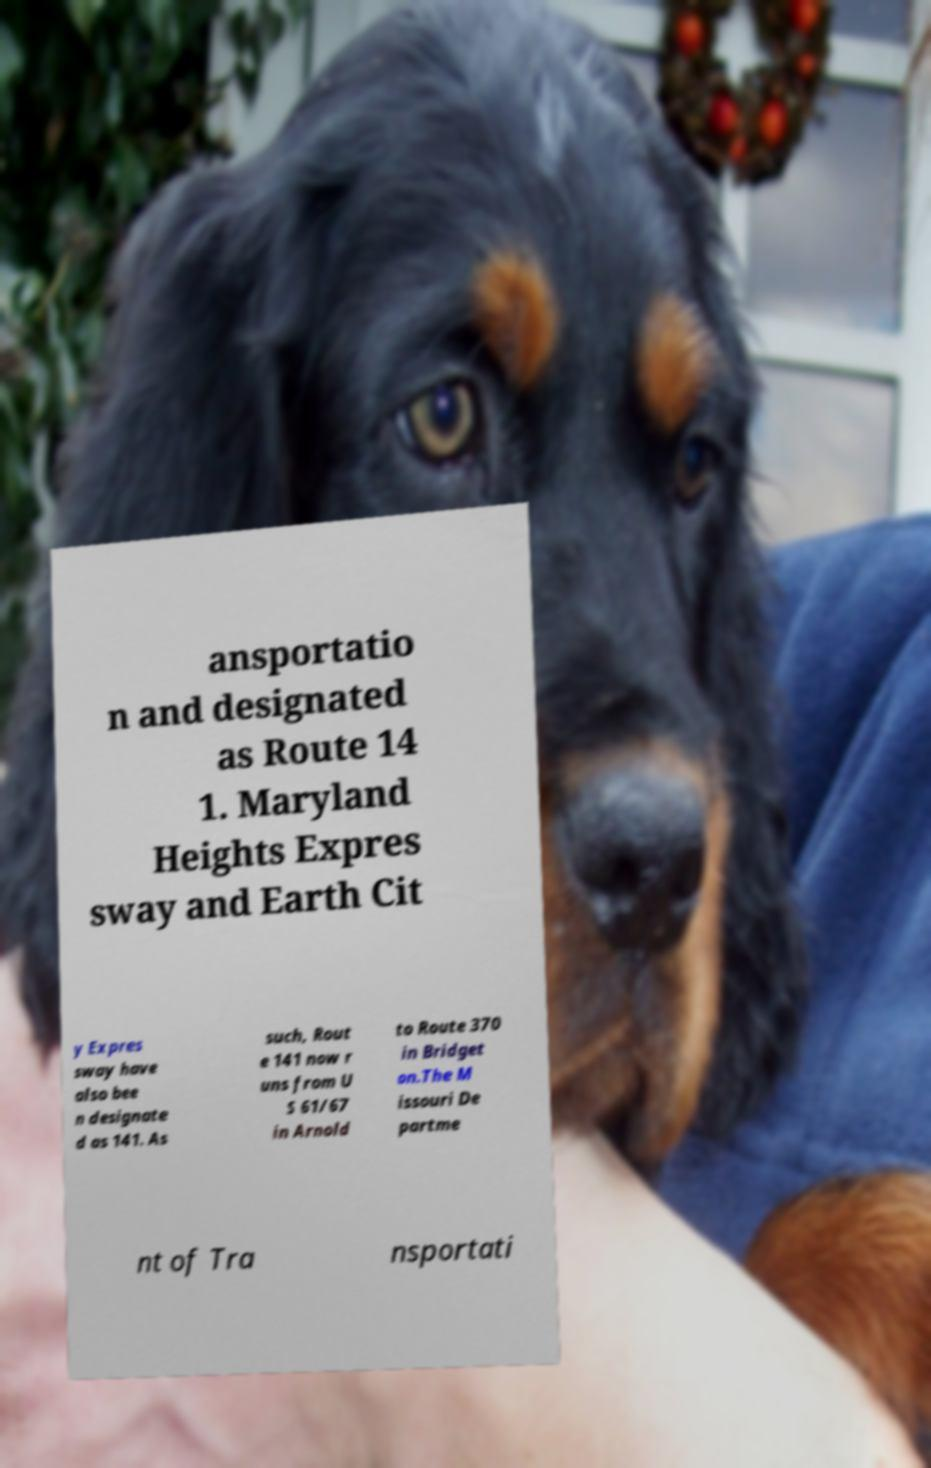Could you extract and type out the text from this image? ansportatio n and designated as Route 14 1. Maryland Heights Expres sway and Earth Cit y Expres sway have also bee n designate d as 141. As such, Rout e 141 now r uns from U S 61/67 in Arnold to Route 370 in Bridget on.The M issouri De partme nt of Tra nsportati 